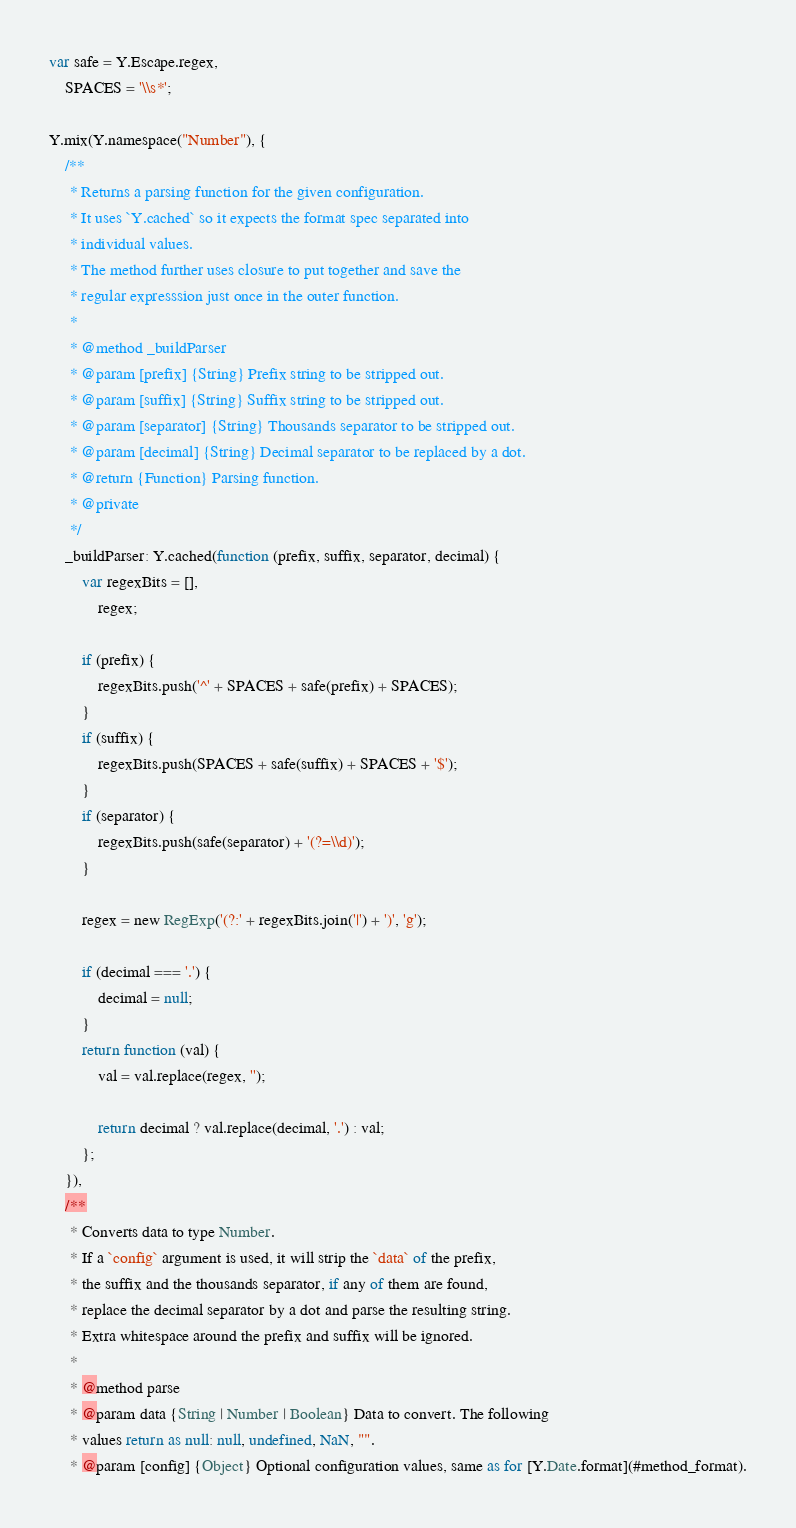Convert code to text. <code><loc_0><loc_0><loc_500><loc_500><_JavaScript_>
var safe = Y.Escape.regex,
    SPACES = '\\s*';

Y.mix(Y.namespace("Number"), {
    /**
     * Returns a parsing function for the given configuration.
     * It uses `Y.cached` so it expects the format spec separated into
     * individual values.
     * The method further uses closure to put together and save the
     * regular expresssion just once in the outer function.
     *
     * @method _buildParser
     * @param [prefix] {String} Prefix string to be stripped out.
     * @param [suffix] {String} Suffix string to be stripped out.
     * @param [separator] {String} Thousands separator to be stripped out.
     * @param [decimal] {String} Decimal separator to be replaced by a dot.
     * @return {Function} Parsing function.
     * @private
     */
    _buildParser: Y.cached(function (prefix, suffix, separator, decimal) {
        var regexBits = [],
            regex;

        if (prefix) {
            regexBits.push('^' + SPACES + safe(prefix) + SPACES);
        }
        if (suffix) {
            regexBits.push(SPACES + safe(suffix) + SPACES + '$');
        }
        if (separator) {
            regexBits.push(safe(separator) + '(?=\\d)');
        }

        regex = new RegExp('(?:' + regexBits.join('|') + ')', 'g');

        if (decimal === '.') {
            decimal = null;
        }
        return function (val) {
            val = val.replace(regex, '');

            return decimal ? val.replace(decimal, '.') : val;
        };
    }),
    /**
     * Converts data to type Number.
     * If a `config` argument is used, it will strip the `data` of the prefix,
     * the suffix and the thousands separator, if any of them are found,
     * replace the decimal separator by a dot and parse the resulting string.
     * Extra whitespace around the prefix and suffix will be ignored.
     *
     * @method parse
     * @param data {String | Number | Boolean} Data to convert. The following
     * values return as null: null, undefined, NaN, "".
     * @param [config] {Object} Optional configuration values, same as for [Y.Date.format](#method_format).</code> 